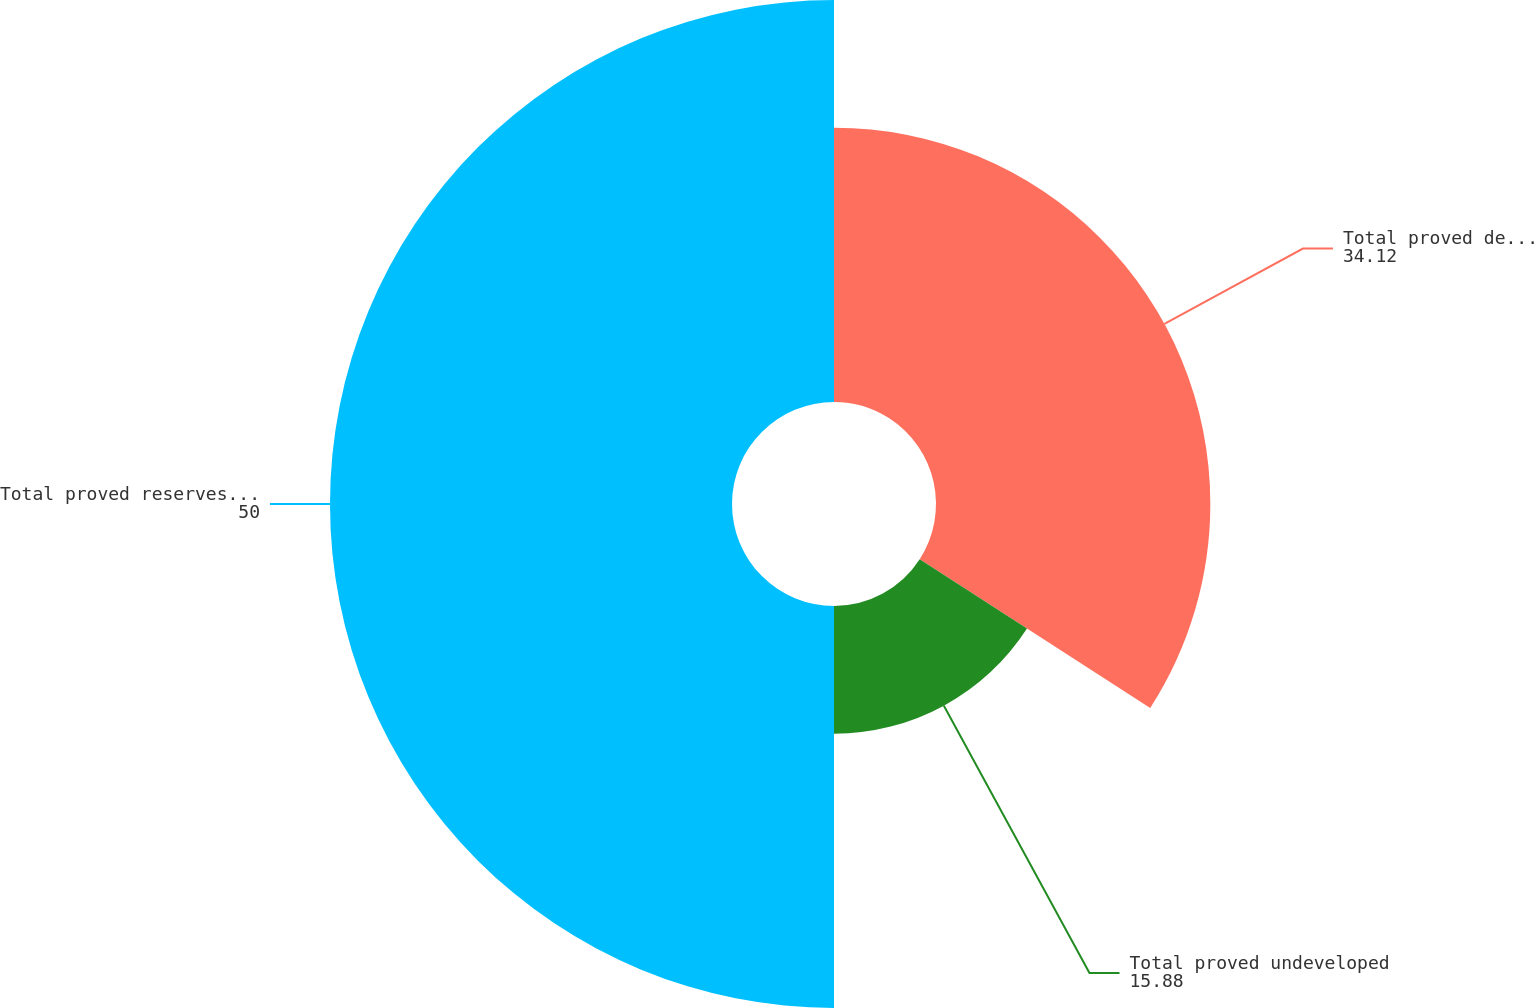<chart> <loc_0><loc_0><loc_500><loc_500><pie_chart><fcel>Total proved developed<fcel>Total proved undeveloped<fcel>Total proved reserves (mmboe)<nl><fcel>34.12%<fcel>15.88%<fcel>50.0%<nl></chart> 